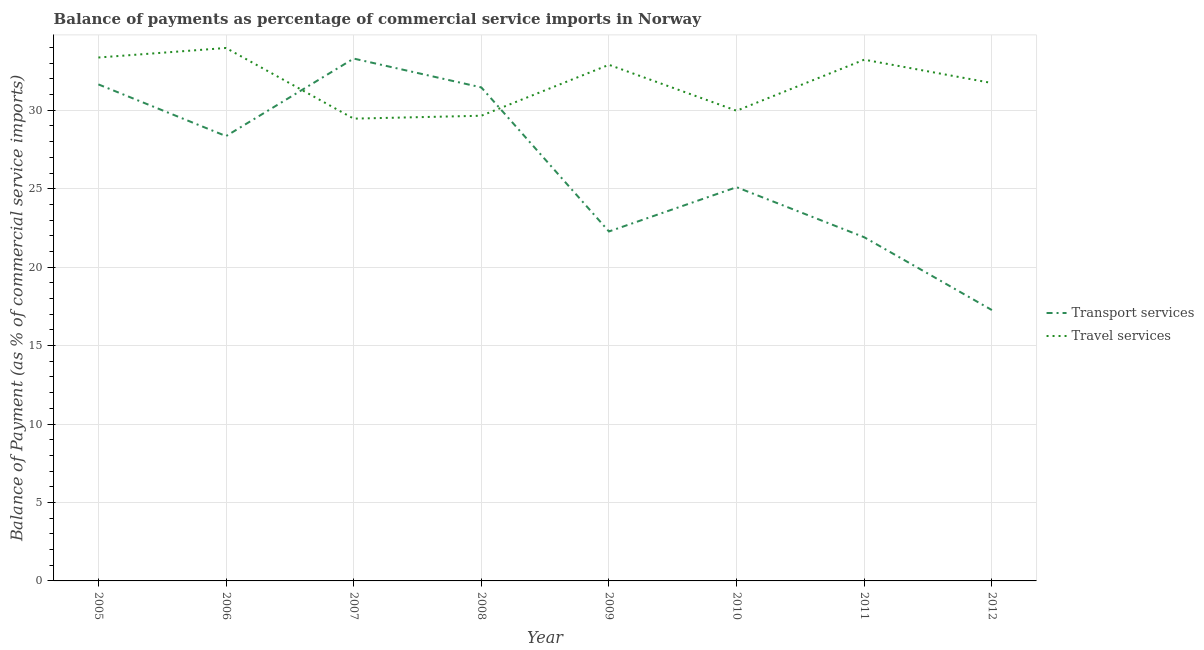How many different coloured lines are there?
Make the answer very short. 2. Is the number of lines equal to the number of legend labels?
Provide a short and direct response. Yes. What is the balance of payments of travel services in 2007?
Provide a succinct answer. 29.47. Across all years, what is the maximum balance of payments of transport services?
Provide a succinct answer. 33.3. Across all years, what is the minimum balance of payments of transport services?
Make the answer very short. 17.27. What is the total balance of payments of travel services in the graph?
Give a very brief answer. 254.29. What is the difference between the balance of payments of transport services in 2007 and that in 2009?
Make the answer very short. 11.02. What is the difference between the balance of payments of travel services in 2008 and the balance of payments of transport services in 2005?
Provide a succinct answer. -2. What is the average balance of payments of transport services per year?
Offer a terse response. 26.41. In the year 2007, what is the difference between the balance of payments of transport services and balance of payments of travel services?
Make the answer very short. 3.83. In how many years, is the balance of payments of transport services greater than 18 %?
Your answer should be compact. 7. What is the ratio of the balance of payments of travel services in 2006 to that in 2011?
Offer a very short reply. 1.02. Is the balance of payments of travel services in 2008 less than that in 2009?
Keep it short and to the point. Yes. What is the difference between the highest and the second highest balance of payments of travel services?
Your response must be concise. 0.61. What is the difference between the highest and the lowest balance of payments of travel services?
Give a very brief answer. 4.5. Does the balance of payments of transport services monotonically increase over the years?
Keep it short and to the point. No. Is the balance of payments of transport services strictly greater than the balance of payments of travel services over the years?
Provide a short and direct response. No. Is the balance of payments of travel services strictly less than the balance of payments of transport services over the years?
Make the answer very short. No. How many lines are there?
Give a very brief answer. 2. Does the graph contain any zero values?
Provide a succinct answer. No. Where does the legend appear in the graph?
Your response must be concise. Center right. What is the title of the graph?
Ensure brevity in your answer.  Balance of payments as percentage of commercial service imports in Norway. What is the label or title of the Y-axis?
Keep it short and to the point. Balance of Payment (as % of commercial service imports). What is the Balance of Payment (as % of commercial service imports) in Transport services in 2005?
Offer a very short reply. 31.65. What is the Balance of Payment (as % of commercial service imports) of Travel services in 2005?
Offer a very short reply. 33.36. What is the Balance of Payment (as % of commercial service imports) in Transport services in 2006?
Ensure brevity in your answer.  28.35. What is the Balance of Payment (as % of commercial service imports) in Travel services in 2006?
Offer a terse response. 33.97. What is the Balance of Payment (as % of commercial service imports) of Transport services in 2007?
Offer a terse response. 33.3. What is the Balance of Payment (as % of commercial service imports) of Travel services in 2007?
Your response must be concise. 29.47. What is the Balance of Payment (as % of commercial service imports) in Transport services in 2008?
Offer a terse response. 31.46. What is the Balance of Payment (as % of commercial service imports) in Travel services in 2008?
Make the answer very short. 29.65. What is the Balance of Payment (as % of commercial service imports) in Transport services in 2009?
Offer a very short reply. 22.28. What is the Balance of Payment (as % of commercial service imports) of Travel services in 2009?
Ensure brevity in your answer.  32.9. What is the Balance of Payment (as % of commercial service imports) in Transport services in 2010?
Provide a short and direct response. 25.1. What is the Balance of Payment (as % of commercial service imports) of Travel services in 2010?
Ensure brevity in your answer.  29.97. What is the Balance of Payment (as % of commercial service imports) in Transport services in 2011?
Offer a terse response. 21.91. What is the Balance of Payment (as % of commercial service imports) of Travel services in 2011?
Offer a very short reply. 33.22. What is the Balance of Payment (as % of commercial service imports) in Transport services in 2012?
Ensure brevity in your answer.  17.27. What is the Balance of Payment (as % of commercial service imports) in Travel services in 2012?
Your response must be concise. 31.74. Across all years, what is the maximum Balance of Payment (as % of commercial service imports) in Transport services?
Make the answer very short. 33.3. Across all years, what is the maximum Balance of Payment (as % of commercial service imports) in Travel services?
Provide a short and direct response. 33.97. Across all years, what is the minimum Balance of Payment (as % of commercial service imports) in Transport services?
Offer a terse response. 17.27. Across all years, what is the minimum Balance of Payment (as % of commercial service imports) of Travel services?
Your response must be concise. 29.47. What is the total Balance of Payment (as % of commercial service imports) in Transport services in the graph?
Offer a terse response. 211.31. What is the total Balance of Payment (as % of commercial service imports) of Travel services in the graph?
Your response must be concise. 254.29. What is the difference between the Balance of Payment (as % of commercial service imports) of Transport services in 2005 and that in 2006?
Offer a very short reply. 3.3. What is the difference between the Balance of Payment (as % of commercial service imports) in Travel services in 2005 and that in 2006?
Offer a very short reply. -0.61. What is the difference between the Balance of Payment (as % of commercial service imports) of Transport services in 2005 and that in 2007?
Give a very brief answer. -1.65. What is the difference between the Balance of Payment (as % of commercial service imports) of Travel services in 2005 and that in 2007?
Your answer should be very brief. 3.9. What is the difference between the Balance of Payment (as % of commercial service imports) in Transport services in 2005 and that in 2008?
Make the answer very short. 0.19. What is the difference between the Balance of Payment (as % of commercial service imports) in Travel services in 2005 and that in 2008?
Keep it short and to the point. 3.71. What is the difference between the Balance of Payment (as % of commercial service imports) in Transport services in 2005 and that in 2009?
Give a very brief answer. 9.38. What is the difference between the Balance of Payment (as % of commercial service imports) in Travel services in 2005 and that in 2009?
Offer a terse response. 0.46. What is the difference between the Balance of Payment (as % of commercial service imports) in Transport services in 2005 and that in 2010?
Your response must be concise. 6.55. What is the difference between the Balance of Payment (as % of commercial service imports) in Travel services in 2005 and that in 2010?
Provide a short and direct response. 3.39. What is the difference between the Balance of Payment (as % of commercial service imports) in Transport services in 2005 and that in 2011?
Provide a short and direct response. 9.74. What is the difference between the Balance of Payment (as % of commercial service imports) of Travel services in 2005 and that in 2011?
Your response must be concise. 0.14. What is the difference between the Balance of Payment (as % of commercial service imports) in Transport services in 2005 and that in 2012?
Give a very brief answer. 14.39. What is the difference between the Balance of Payment (as % of commercial service imports) of Travel services in 2005 and that in 2012?
Your answer should be compact. 1.63. What is the difference between the Balance of Payment (as % of commercial service imports) in Transport services in 2006 and that in 2007?
Make the answer very short. -4.94. What is the difference between the Balance of Payment (as % of commercial service imports) in Travel services in 2006 and that in 2007?
Make the answer very short. 4.5. What is the difference between the Balance of Payment (as % of commercial service imports) in Transport services in 2006 and that in 2008?
Offer a very short reply. -3.1. What is the difference between the Balance of Payment (as % of commercial service imports) in Travel services in 2006 and that in 2008?
Offer a terse response. 4.32. What is the difference between the Balance of Payment (as % of commercial service imports) in Transport services in 2006 and that in 2009?
Keep it short and to the point. 6.08. What is the difference between the Balance of Payment (as % of commercial service imports) in Travel services in 2006 and that in 2009?
Your response must be concise. 1.07. What is the difference between the Balance of Payment (as % of commercial service imports) in Transport services in 2006 and that in 2010?
Ensure brevity in your answer.  3.26. What is the difference between the Balance of Payment (as % of commercial service imports) in Travel services in 2006 and that in 2010?
Your response must be concise. 4. What is the difference between the Balance of Payment (as % of commercial service imports) in Transport services in 2006 and that in 2011?
Your answer should be very brief. 6.45. What is the difference between the Balance of Payment (as % of commercial service imports) of Travel services in 2006 and that in 2011?
Your answer should be compact. 0.75. What is the difference between the Balance of Payment (as % of commercial service imports) in Transport services in 2006 and that in 2012?
Your response must be concise. 11.09. What is the difference between the Balance of Payment (as % of commercial service imports) of Travel services in 2006 and that in 2012?
Offer a very short reply. 2.23. What is the difference between the Balance of Payment (as % of commercial service imports) in Transport services in 2007 and that in 2008?
Provide a short and direct response. 1.84. What is the difference between the Balance of Payment (as % of commercial service imports) in Travel services in 2007 and that in 2008?
Ensure brevity in your answer.  -0.19. What is the difference between the Balance of Payment (as % of commercial service imports) of Transport services in 2007 and that in 2009?
Provide a succinct answer. 11.02. What is the difference between the Balance of Payment (as % of commercial service imports) of Travel services in 2007 and that in 2009?
Offer a terse response. -3.43. What is the difference between the Balance of Payment (as % of commercial service imports) in Transport services in 2007 and that in 2010?
Your answer should be compact. 8.2. What is the difference between the Balance of Payment (as % of commercial service imports) of Travel services in 2007 and that in 2010?
Your answer should be very brief. -0.5. What is the difference between the Balance of Payment (as % of commercial service imports) in Transport services in 2007 and that in 2011?
Ensure brevity in your answer.  11.39. What is the difference between the Balance of Payment (as % of commercial service imports) of Travel services in 2007 and that in 2011?
Give a very brief answer. -3.76. What is the difference between the Balance of Payment (as % of commercial service imports) in Transport services in 2007 and that in 2012?
Offer a terse response. 16.03. What is the difference between the Balance of Payment (as % of commercial service imports) in Travel services in 2007 and that in 2012?
Provide a short and direct response. -2.27. What is the difference between the Balance of Payment (as % of commercial service imports) of Transport services in 2008 and that in 2009?
Offer a very short reply. 9.18. What is the difference between the Balance of Payment (as % of commercial service imports) in Travel services in 2008 and that in 2009?
Offer a terse response. -3.25. What is the difference between the Balance of Payment (as % of commercial service imports) in Transport services in 2008 and that in 2010?
Your answer should be compact. 6.36. What is the difference between the Balance of Payment (as % of commercial service imports) of Travel services in 2008 and that in 2010?
Offer a very short reply. -0.32. What is the difference between the Balance of Payment (as % of commercial service imports) of Transport services in 2008 and that in 2011?
Provide a short and direct response. 9.55. What is the difference between the Balance of Payment (as % of commercial service imports) of Travel services in 2008 and that in 2011?
Give a very brief answer. -3.57. What is the difference between the Balance of Payment (as % of commercial service imports) of Transport services in 2008 and that in 2012?
Give a very brief answer. 14.19. What is the difference between the Balance of Payment (as % of commercial service imports) of Travel services in 2008 and that in 2012?
Your answer should be compact. -2.08. What is the difference between the Balance of Payment (as % of commercial service imports) in Transport services in 2009 and that in 2010?
Ensure brevity in your answer.  -2.82. What is the difference between the Balance of Payment (as % of commercial service imports) in Travel services in 2009 and that in 2010?
Provide a succinct answer. 2.93. What is the difference between the Balance of Payment (as % of commercial service imports) in Transport services in 2009 and that in 2011?
Provide a succinct answer. 0.37. What is the difference between the Balance of Payment (as % of commercial service imports) of Travel services in 2009 and that in 2011?
Provide a succinct answer. -0.33. What is the difference between the Balance of Payment (as % of commercial service imports) of Transport services in 2009 and that in 2012?
Your response must be concise. 5.01. What is the difference between the Balance of Payment (as % of commercial service imports) of Travel services in 2009 and that in 2012?
Provide a short and direct response. 1.16. What is the difference between the Balance of Payment (as % of commercial service imports) of Transport services in 2010 and that in 2011?
Offer a terse response. 3.19. What is the difference between the Balance of Payment (as % of commercial service imports) of Travel services in 2010 and that in 2011?
Offer a terse response. -3.25. What is the difference between the Balance of Payment (as % of commercial service imports) of Transport services in 2010 and that in 2012?
Give a very brief answer. 7.83. What is the difference between the Balance of Payment (as % of commercial service imports) in Travel services in 2010 and that in 2012?
Keep it short and to the point. -1.77. What is the difference between the Balance of Payment (as % of commercial service imports) of Transport services in 2011 and that in 2012?
Give a very brief answer. 4.64. What is the difference between the Balance of Payment (as % of commercial service imports) in Travel services in 2011 and that in 2012?
Ensure brevity in your answer.  1.49. What is the difference between the Balance of Payment (as % of commercial service imports) in Transport services in 2005 and the Balance of Payment (as % of commercial service imports) in Travel services in 2006?
Keep it short and to the point. -2.32. What is the difference between the Balance of Payment (as % of commercial service imports) in Transport services in 2005 and the Balance of Payment (as % of commercial service imports) in Travel services in 2007?
Offer a very short reply. 2.18. What is the difference between the Balance of Payment (as % of commercial service imports) of Transport services in 2005 and the Balance of Payment (as % of commercial service imports) of Travel services in 2008?
Make the answer very short. 2. What is the difference between the Balance of Payment (as % of commercial service imports) in Transport services in 2005 and the Balance of Payment (as % of commercial service imports) in Travel services in 2009?
Provide a short and direct response. -1.25. What is the difference between the Balance of Payment (as % of commercial service imports) in Transport services in 2005 and the Balance of Payment (as % of commercial service imports) in Travel services in 2010?
Your answer should be very brief. 1.68. What is the difference between the Balance of Payment (as % of commercial service imports) in Transport services in 2005 and the Balance of Payment (as % of commercial service imports) in Travel services in 2011?
Offer a terse response. -1.57. What is the difference between the Balance of Payment (as % of commercial service imports) in Transport services in 2005 and the Balance of Payment (as % of commercial service imports) in Travel services in 2012?
Keep it short and to the point. -0.09. What is the difference between the Balance of Payment (as % of commercial service imports) in Transport services in 2006 and the Balance of Payment (as % of commercial service imports) in Travel services in 2007?
Your response must be concise. -1.11. What is the difference between the Balance of Payment (as % of commercial service imports) in Transport services in 2006 and the Balance of Payment (as % of commercial service imports) in Travel services in 2008?
Ensure brevity in your answer.  -1.3. What is the difference between the Balance of Payment (as % of commercial service imports) in Transport services in 2006 and the Balance of Payment (as % of commercial service imports) in Travel services in 2009?
Offer a terse response. -4.54. What is the difference between the Balance of Payment (as % of commercial service imports) in Transport services in 2006 and the Balance of Payment (as % of commercial service imports) in Travel services in 2010?
Your answer should be very brief. -1.62. What is the difference between the Balance of Payment (as % of commercial service imports) of Transport services in 2006 and the Balance of Payment (as % of commercial service imports) of Travel services in 2011?
Keep it short and to the point. -4.87. What is the difference between the Balance of Payment (as % of commercial service imports) in Transport services in 2006 and the Balance of Payment (as % of commercial service imports) in Travel services in 2012?
Offer a very short reply. -3.38. What is the difference between the Balance of Payment (as % of commercial service imports) of Transport services in 2007 and the Balance of Payment (as % of commercial service imports) of Travel services in 2008?
Give a very brief answer. 3.64. What is the difference between the Balance of Payment (as % of commercial service imports) in Transport services in 2007 and the Balance of Payment (as % of commercial service imports) in Travel services in 2009?
Ensure brevity in your answer.  0.4. What is the difference between the Balance of Payment (as % of commercial service imports) of Transport services in 2007 and the Balance of Payment (as % of commercial service imports) of Travel services in 2010?
Provide a succinct answer. 3.32. What is the difference between the Balance of Payment (as % of commercial service imports) in Transport services in 2007 and the Balance of Payment (as % of commercial service imports) in Travel services in 2011?
Provide a succinct answer. 0.07. What is the difference between the Balance of Payment (as % of commercial service imports) of Transport services in 2007 and the Balance of Payment (as % of commercial service imports) of Travel services in 2012?
Your answer should be very brief. 1.56. What is the difference between the Balance of Payment (as % of commercial service imports) in Transport services in 2008 and the Balance of Payment (as % of commercial service imports) in Travel services in 2009?
Provide a succinct answer. -1.44. What is the difference between the Balance of Payment (as % of commercial service imports) in Transport services in 2008 and the Balance of Payment (as % of commercial service imports) in Travel services in 2010?
Offer a terse response. 1.49. What is the difference between the Balance of Payment (as % of commercial service imports) in Transport services in 2008 and the Balance of Payment (as % of commercial service imports) in Travel services in 2011?
Your answer should be compact. -1.77. What is the difference between the Balance of Payment (as % of commercial service imports) of Transport services in 2008 and the Balance of Payment (as % of commercial service imports) of Travel services in 2012?
Your answer should be very brief. -0.28. What is the difference between the Balance of Payment (as % of commercial service imports) in Transport services in 2009 and the Balance of Payment (as % of commercial service imports) in Travel services in 2010?
Provide a succinct answer. -7.7. What is the difference between the Balance of Payment (as % of commercial service imports) of Transport services in 2009 and the Balance of Payment (as % of commercial service imports) of Travel services in 2011?
Your answer should be compact. -10.95. What is the difference between the Balance of Payment (as % of commercial service imports) of Transport services in 2009 and the Balance of Payment (as % of commercial service imports) of Travel services in 2012?
Provide a succinct answer. -9.46. What is the difference between the Balance of Payment (as % of commercial service imports) in Transport services in 2010 and the Balance of Payment (as % of commercial service imports) in Travel services in 2011?
Offer a terse response. -8.13. What is the difference between the Balance of Payment (as % of commercial service imports) in Transport services in 2010 and the Balance of Payment (as % of commercial service imports) in Travel services in 2012?
Your answer should be very brief. -6.64. What is the difference between the Balance of Payment (as % of commercial service imports) of Transport services in 2011 and the Balance of Payment (as % of commercial service imports) of Travel services in 2012?
Offer a very short reply. -9.83. What is the average Balance of Payment (as % of commercial service imports) in Transport services per year?
Provide a short and direct response. 26.41. What is the average Balance of Payment (as % of commercial service imports) of Travel services per year?
Your answer should be compact. 31.79. In the year 2005, what is the difference between the Balance of Payment (as % of commercial service imports) of Transport services and Balance of Payment (as % of commercial service imports) of Travel services?
Provide a succinct answer. -1.71. In the year 2006, what is the difference between the Balance of Payment (as % of commercial service imports) in Transport services and Balance of Payment (as % of commercial service imports) in Travel services?
Make the answer very short. -5.62. In the year 2007, what is the difference between the Balance of Payment (as % of commercial service imports) in Transport services and Balance of Payment (as % of commercial service imports) in Travel services?
Keep it short and to the point. 3.83. In the year 2008, what is the difference between the Balance of Payment (as % of commercial service imports) of Transport services and Balance of Payment (as % of commercial service imports) of Travel services?
Keep it short and to the point. 1.81. In the year 2009, what is the difference between the Balance of Payment (as % of commercial service imports) in Transport services and Balance of Payment (as % of commercial service imports) in Travel services?
Your answer should be very brief. -10.62. In the year 2010, what is the difference between the Balance of Payment (as % of commercial service imports) of Transport services and Balance of Payment (as % of commercial service imports) of Travel services?
Ensure brevity in your answer.  -4.87. In the year 2011, what is the difference between the Balance of Payment (as % of commercial service imports) in Transport services and Balance of Payment (as % of commercial service imports) in Travel services?
Give a very brief answer. -11.32. In the year 2012, what is the difference between the Balance of Payment (as % of commercial service imports) of Transport services and Balance of Payment (as % of commercial service imports) of Travel services?
Your answer should be very brief. -14.47. What is the ratio of the Balance of Payment (as % of commercial service imports) of Transport services in 2005 to that in 2006?
Give a very brief answer. 1.12. What is the ratio of the Balance of Payment (as % of commercial service imports) of Travel services in 2005 to that in 2006?
Ensure brevity in your answer.  0.98. What is the ratio of the Balance of Payment (as % of commercial service imports) of Transport services in 2005 to that in 2007?
Offer a terse response. 0.95. What is the ratio of the Balance of Payment (as % of commercial service imports) in Travel services in 2005 to that in 2007?
Provide a succinct answer. 1.13. What is the ratio of the Balance of Payment (as % of commercial service imports) in Travel services in 2005 to that in 2008?
Your answer should be compact. 1.13. What is the ratio of the Balance of Payment (as % of commercial service imports) in Transport services in 2005 to that in 2009?
Keep it short and to the point. 1.42. What is the ratio of the Balance of Payment (as % of commercial service imports) in Travel services in 2005 to that in 2009?
Provide a succinct answer. 1.01. What is the ratio of the Balance of Payment (as % of commercial service imports) of Transport services in 2005 to that in 2010?
Make the answer very short. 1.26. What is the ratio of the Balance of Payment (as % of commercial service imports) of Travel services in 2005 to that in 2010?
Your answer should be very brief. 1.11. What is the ratio of the Balance of Payment (as % of commercial service imports) of Transport services in 2005 to that in 2011?
Your answer should be very brief. 1.44. What is the ratio of the Balance of Payment (as % of commercial service imports) of Transport services in 2005 to that in 2012?
Your answer should be compact. 1.83. What is the ratio of the Balance of Payment (as % of commercial service imports) in Travel services in 2005 to that in 2012?
Your answer should be very brief. 1.05. What is the ratio of the Balance of Payment (as % of commercial service imports) in Transport services in 2006 to that in 2007?
Offer a very short reply. 0.85. What is the ratio of the Balance of Payment (as % of commercial service imports) of Travel services in 2006 to that in 2007?
Your answer should be compact. 1.15. What is the ratio of the Balance of Payment (as % of commercial service imports) in Transport services in 2006 to that in 2008?
Offer a very short reply. 0.9. What is the ratio of the Balance of Payment (as % of commercial service imports) of Travel services in 2006 to that in 2008?
Offer a terse response. 1.15. What is the ratio of the Balance of Payment (as % of commercial service imports) of Transport services in 2006 to that in 2009?
Keep it short and to the point. 1.27. What is the ratio of the Balance of Payment (as % of commercial service imports) in Travel services in 2006 to that in 2009?
Your answer should be very brief. 1.03. What is the ratio of the Balance of Payment (as % of commercial service imports) of Transport services in 2006 to that in 2010?
Ensure brevity in your answer.  1.13. What is the ratio of the Balance of Payment (as % of commercial service imports) in Travel services in 2006 to that in 2010?
Make the answer very short. 1.13. What is the ratio of the Balance of Payment (as % of commercial service imports) of Transport services in 2006 to that in 2011?
Your answer should be very brief. 1.29. What is the ratio of the Balance of Payment (as % of commercial service imports) in Travel services in 2006 to that in 2011?
Your answer should be compact. 1.02. What is the ratio of the Balance of Payment (as % of commercial service imports) in Transport services in 2006 to that in 2012?
Offer a very short reply. 1.64. What is the ratio of the Balance of Payment (as % of commercial service imports) in Travel services in 2006 to that in 2012?
Offer a terse response. 1.07. What is the ratio of the Balance of Payment (as % of commercial service imports) of Transport services in 2007 to that in 2008?
Keep it short and to the point. 1.06. What is the ratio of the Balance of Payment (as % of commercial service imports) of Travel services in 2007 to that in 2008?
Offer a terse response. 0.99. What is the ratio of the Balance of Payment (as % of commercial service imports) in Transport services in 2007 to that in 2009?
Make the answer very short. 1.49. What is the ratio of the Balance of Payment (as % of commercial service imports) of Travel services in 2007 to that in 2009?
Ensure brevity in your answer.  0.9. What is the ratio of the Balance of Payment (as % of commercial service imports) of Transport services in 2007 to that in 2010?
Ensure brevity in your answer.  1.33. What is the ratio of the Balance of Payment (as % of commercial service imports) in Travel services in 2007 to that in 2010?
Provide a short and direct response. 0.98. What is the ratio of the Balance of Payment (as % of commercial service imports) in Transport services in 2007 to that in 2011?
Your answer should be compact. 1.52. What is the ratio of the Balance of Payment (as % of commercial service imports) of Travel services in 2007 to that in 2011?
Provide a succinct answer. 0.89. What is the ratio of the Balance of Payment (as % of commercial service imports) in Transport services in 2007 to that in 2012?
Your response must be concise. 1.93. What is the ratio of the Balance of Payment (as % of commercial service imports) in Travel services in 2007 to that in 2012?
Your response must be concise. 0.93. What is the ratio of the Balance of Payment (as % of commercial service imports) in Transport services in 2008 to that in 2009?
Give a very brief answer. 1.41. What is the ratio of the Balance of Payment (as % of commercial service imports) of Travel services in 2008 to that in 2009?
Ensure brevity in your answer.  0.9. What is the ratio of the Balance of Payment (as % of commercial service imports) in Transport services in 2008 to that in 2010?
Offer a terse response. 1.25. What is the ratio of the Balance of Payment (as % of commercial service imports) in Travel services in 2008 to that in 2010?
Keep it short and to the point. 0.99. What is the ratio of the Balance of Payment (as % of commercial service imports) of Transport services in 2008 to that in 2011?
Your answer should be very brief. 1.44. What is the ratio of the Balance of Payment (as % of commercial service imports) of Travel services in 2008 to that in 2011?
Give a very brief answer. 0.89. What is the ratio of the Balance of Payment (as % of commercial service imports) of Transport services in 2008 to that in 2012?
Give a very brief answer. 1.82. What is the ratio of the Balance of Payment (as % of commercial service imports) of Travel services in 2008 to that in 2012?
Ensure brevity in your answer.  0.93. What is the ratio of the Balance of Payment (as % of commercial service imports) in Transport services in 2009 to that in 2010?
Your answer should be compact. 0.89. What is the ratio of the Balance of Payment (as % of commercial service imports) of Travel services in 2009 to that in 2010?
Ensure brevity in your answer.  1.1. What is the ratio of the Balance of Payment (as % of commercial service imports) in Transport services in 2009 to that in 2011?
Give a very brief answer. 1.02. What is the ratio of the Balance of Payment (as % of commercial service imports) in Travel services in 2009 to that in 2011?
Keep it short and to the point. 0.99. What is the ratio of the Balance of Payment (as % of commercial service imports) in Transport services in 2009 to that in 2012?
Your response must be concise. 1.29. What is the ratio of the Balance of Payment (as % of commercial service imports) of Travel services in 2009 to that in 2012?
Your answer should be compact. 1.04. What is the ratio of the Balance of Payment (as % of commercial service imports) of Transport services in 2010 to that in 2011?
Your answer should be very brief. 1.15. What is the ratio of the Balance of Payment (as % of commercial service imports) of Travel services in 2010 to that in 2011?
Your response must be concise. 0.9. What is the ratio of the Balance of Payment (as % of commercial service imports) in Transport services in 2010 to that in 2012?
Keep it short and to the point. 1.45. What is the ratio of the Balance of Payment (as % of commercial service imports) in Travel services in 2010 to that in 2012?
Your answer should be compact. 0.94. What is the ratio of the Balance of Payment (as % of commercial service imports) in Transport services in 2011 to that in 2012?
Your answer should be compact. 1.27. What is the ratio of the Balance of Payment (as % of commercial service imports) in Travel services in 2011 to that in 2012?
Your answer should be very brief. 1.05. What is the difference between the highest and the second highest Balance of Payment (as % of commercial service imports) in Transport services?
Your answer should be very brief. 1.65. What is the difference between the highest and the second highest Balance of Payment (as % of commercial service imports) of Travel services?
Your answer should be very brief. 0.61. What is the difference between the highest and the lowest Balance of Payment (as % of commercial service imports) of Transport services?
Provide a succinct answer. 16.03. What is the difference between the highest and the lowest Balance of Payment (as % of commercial service imports) in Travel services?
Offer a very short reply. 4.5. 